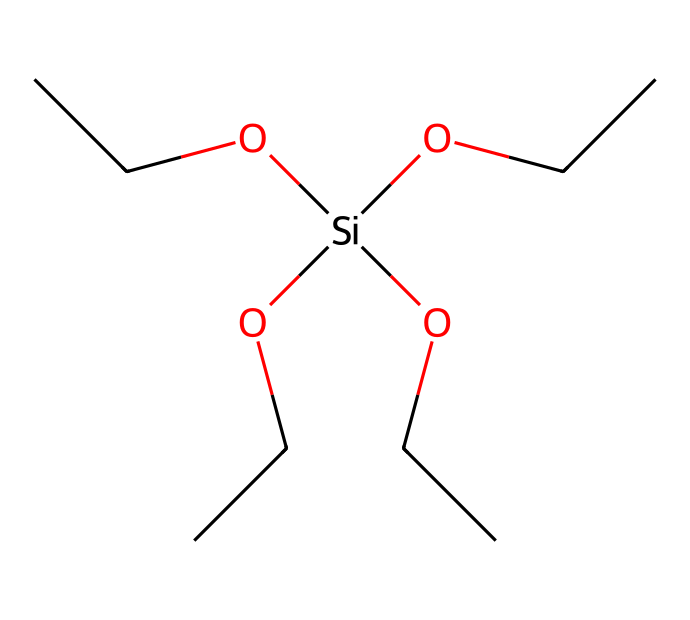What is the molecular formula of tetraethoxysilane? To find the molecular formula, we identify the constituent elements and their counts from the SMILES representation. The formula includes four ethoxy groups (C2H5O) and one silicon atom (Si). Counting all atoms gives C8H20O4Si.
Answer: C8H20O4Si How many oxygen atoms are present in the structure? The chemical contains four ethoxy (OCC) groups, each contributing one oxygen atom to the total count. Therefore, there are four oxygen atoms in total.
Answer: 4 What type of chemical reaction is tetraethoxysilane typically involved in when forming coatings? Tetraethoxysilane undergoes hydrolysis and condensation reactions to form silica networks that are used in coatings.
Answer: hydrolysis Which structural feature indicates that tetraethoxysilane is a silane? The presence of a silicon atom bonded to organic groups (four ethoxy groups in this case) indicates it is a silane, as all silanes have a central silicon atom hybridized with surrounding groups.
Answer: silicon atom What is the significance of the ethoxy groups in this compound? The ethoxy groups enhance the solubility of the silane in organic solvents and help in the formation of stable silica networks after polymerization, which is crucial for anti-reflective coatings.
Answer: solubility 